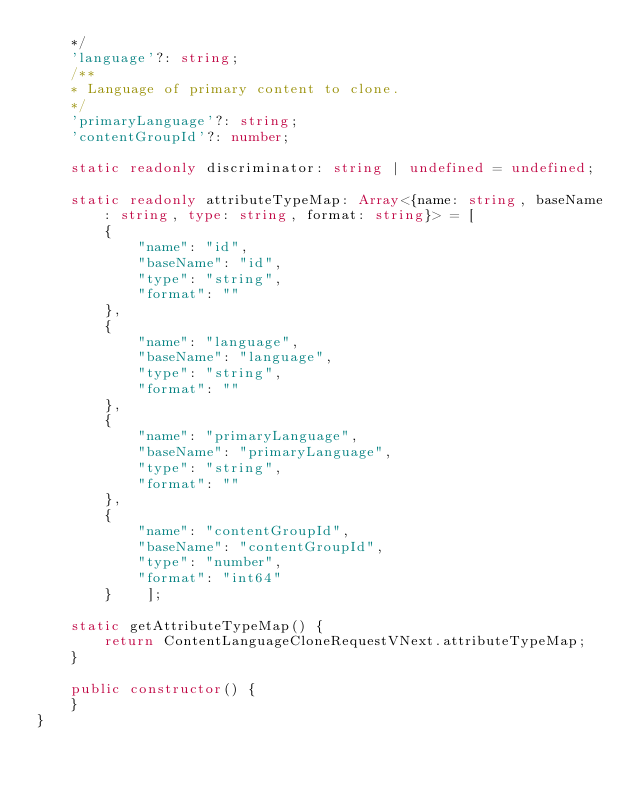Convert code to text. <code><loc_0><loc_0><loc_500><loc_500><_TypeScript_>    */
    'language'?: string;
    /**
    * Language of primary content to clone.
    */
    'primaryLanguage'?: string;
    'contentGroupId'?: number;

    static readonly discriminator: string | undefined = undefined;

    static readonly attributeTypeMap: Array<{name: string, baseName: string, type: string, format: string}> = [
        {
            "name": "id",
            "baseName": "id",
            "type": "string",
            "format": ""
        },
        {
            "name": "language",
            "baseName": "language",
            "type": "string",
            "format": ""
        },
        {
            "name": "primaryLanguage",
            "baseName": "primaryLanguage",
            "type": "string",
            "format": ""
        },
        {
            "name": "contentGroupId",
            "baseName": "contentGroupId",
            "type": "number",
            "format": "int64"
        }    ];

    static getAttributeTypeMap() {
        return ContentLanguageCloneRequestVNext.attributeTypeMap;
    }

    public constructor() {
    }
}

</code> 